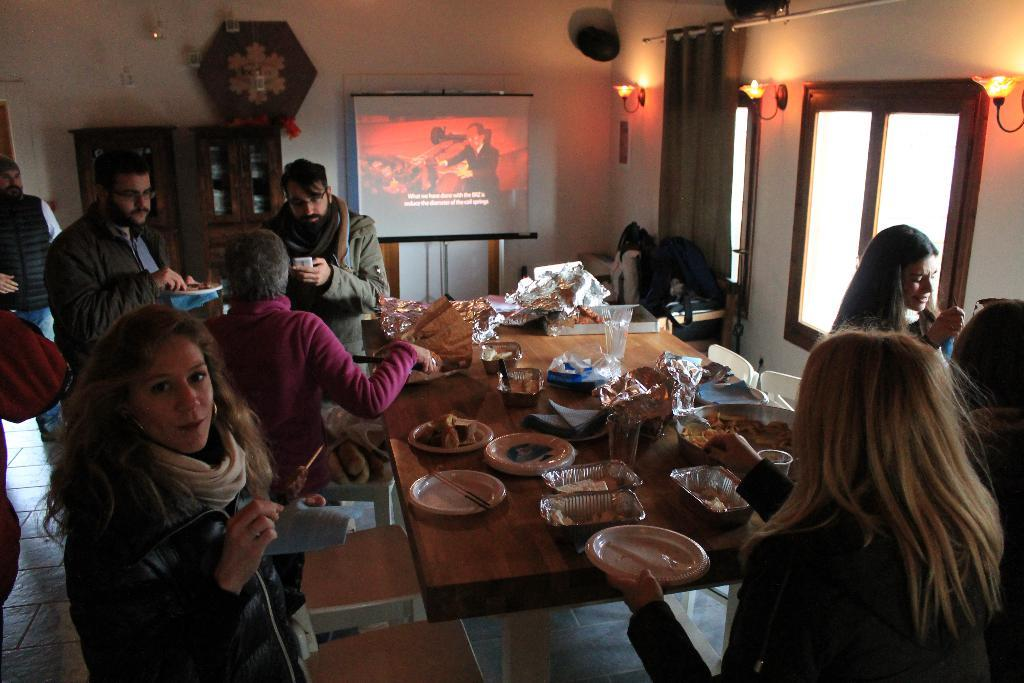What are the people in the image doing? The people in the image are standing and holding plates in their hands. What can be seen on the table in the image? There are food plates and glasses on the table. What is the purpose of the projector screen in the image? The projector screen is likely used for displaying visuals or presentations. What type of window treatment is present in the image? There are curtains on the windows in the image. What type of gold jewelry is the person wearing in the image? There is no gold jewelry visible in the image. What holiday is being celebrated in the image? There is no indication of a holiday being celebrated in the image. 